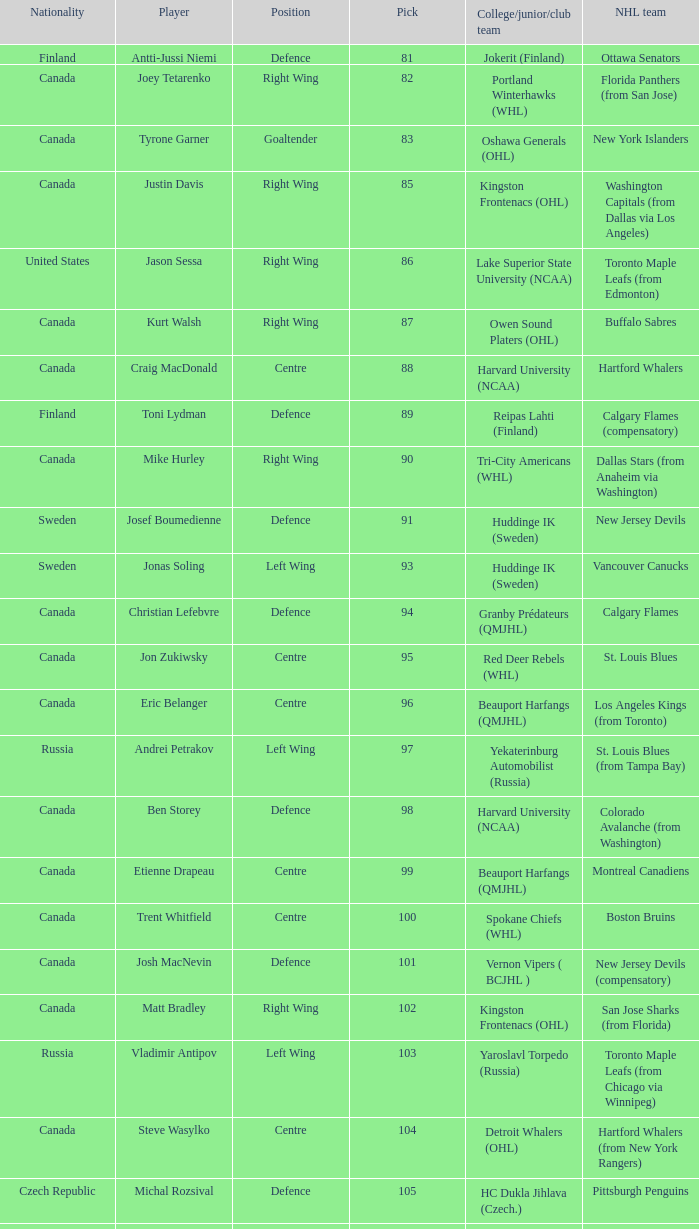How many players came from college team reipas lahti (finland)? 1.0. 